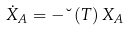Convert formula to latex. <formula><loc_0><loc_0><loc_500><loc_500>\dot { X } _ { A } = - \lambda \left ( T \right ) X _ { A }</formula> 